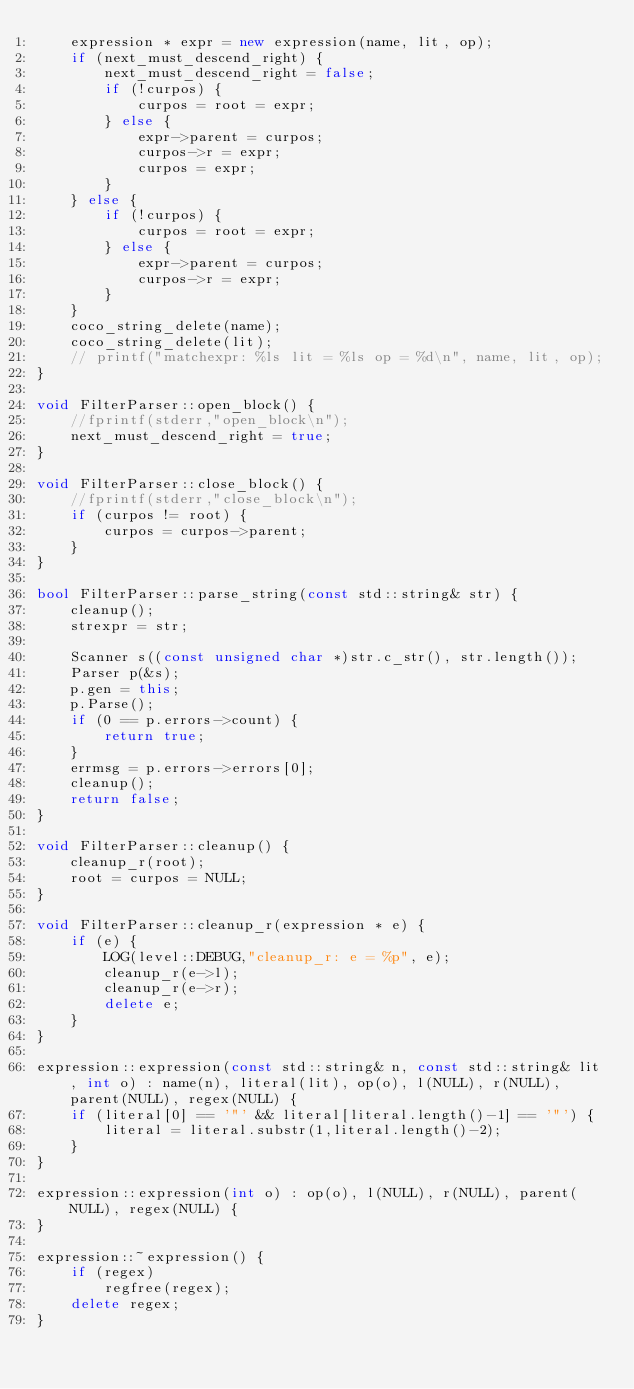<code> <loc_0><loc_0><loc_500><loc_500><_C++_>	expression * expr = new expression(name, lit, op);
	if (next_must_descend_right) {
		next_must_descend_right = false;
		if (!curpos) {
			curpos = root = expr;
		} else {
			expr->parent = curpos;
			curpos->r = expr;
			curpos = expr;
		}
	} else {
		if (!curpos) {
			curpos = root = expr;
		} else {
			expr->parent = curpos;
			curpos->r = expr;
		}
	}
	coco_string_delete(name);
	coco_string_delete(lit);
	// printf("matchexpr: %ls lit = %ls op = %d\n", name, lit, op);
}

void FilterParser::open_block() {
	//fprintf(stderr,"open_block\n");
	next_must_descend_right = true;
}

void FilterParser::close_block() {
	//fprintf(stderr,"close_block\n");
	if (curpos != root) {
		curpos = curpos->parent;
	}
}

bool FilterParser::parse_string(const std::string& str) {
	cleanup();
	strexpr = str;

	Scanner s((const unsigned char *)str.c_str(), str.length());
	Parser p(&s);
	p.gen = this;
	p.Parse();
	if (0 == p.errors->count) {
		return true;
	}
	errmsg = p.errors->errors[0];
	cleanup();
	return false;
}

void FilterParser::cleanup() {
	cleanup_r(root);
	root = curpos = NULL;
}

void FilterParser::cleanup_r(expression * e) {
	if (e) {
		LOG(level::DEBUG,"cleanup_r: e = %p", e);
		cleanup_r(e->l);
		cleanup_r(e->r);
		delete e;
	}
}

expression::expression(const std::string& n, const std::string& lit, int o) : name(n), literal(lit), op(o), l(NULL), r(NULL), parent(NULL), regex(NULL) {
	if (literal[0] == '"' && literal[literal.length()-1] == '"') {
		literal = literal.substr(1,literal.length()-2);
	}
}

expression::expression(int o) : op(o), l(NULL), r(NULL), parent(NULL), regex(NULL) {
}

expression::~expression() {
	if (regex)
		regfree(regex);
	delete regex;
}
</code> 